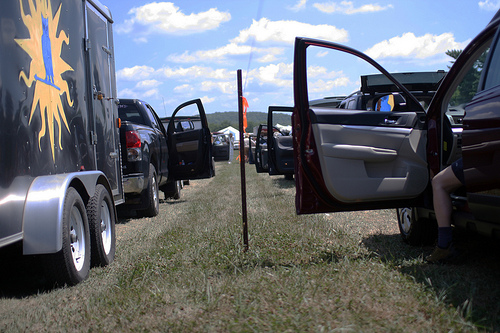<image>
Can you confirm if the door is behind the pole? Yes. From this viewpoint, the door is positioned behind the pole, with the pole partially or fully occluding the door. 